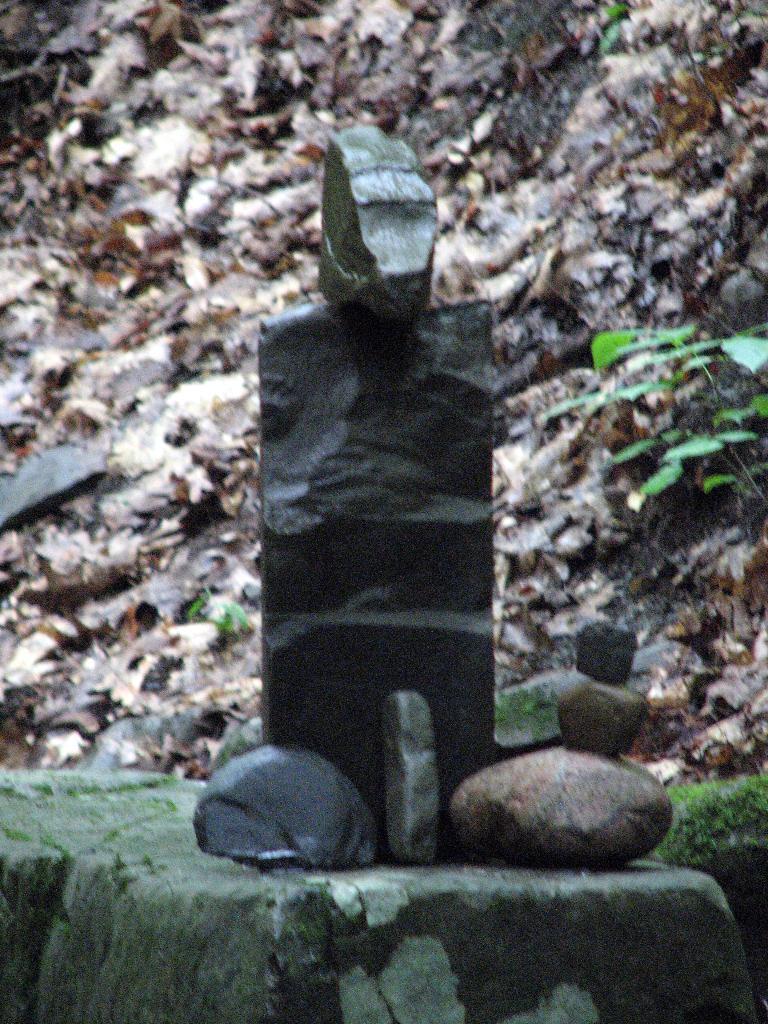Please provide a concise description of this image. In this picture there are stones. At the back there are plants and their might be a rock. 